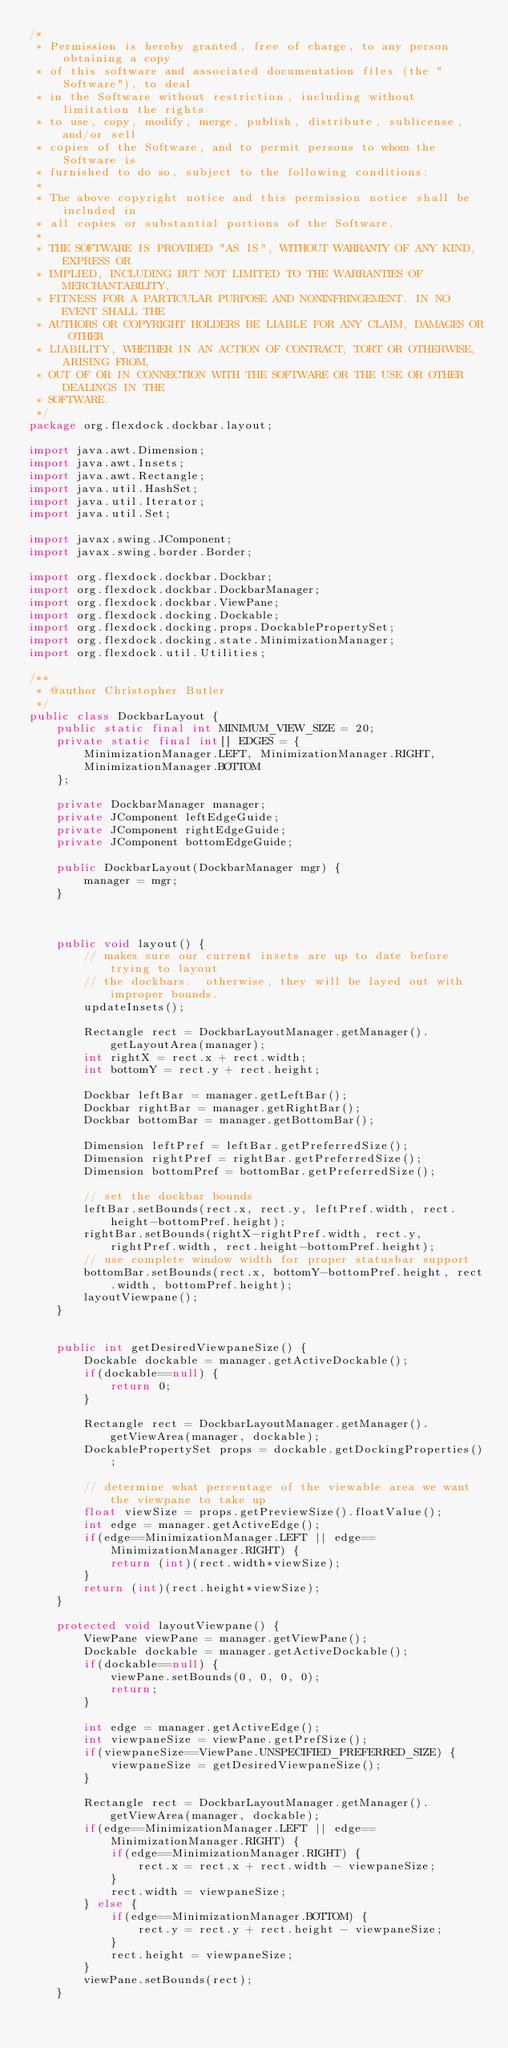<code> <loc_0><loc_0><loc_500><loc_500><_Java_>/*
 * Permission is hereby granted, free of charge, to any person obtaining a copy
 * of this software and associated documentation files (the "Software"), to deal
 * in the Software without restriction, including without limitation the rights
 * to use, copy, modify, merge, publish, distribute, sublicense, and/or sell
 * copies of the Software, and to permit persons to whom the Software is
 * furnished to do so, subject to the following conditions:
 *
 * The above copyright notice and this permission notice shall be included in
 * all copies or substantial portions of the Software.
 *
 * THE SOFTWARE IS PROVIDED "AS IS", WITHOUT WARRANTY OF ANY KIND, EXPRESS OR
 * IMPLIED, INCLUDING BUT NOT LIMITED TO THE WARRANTIES OF MERCHANTABILITY,
 * FITNESS FOR A PARTICULAR PURPOSE AND NONINFRINGEMENT. IN NO EVENT SHALL THE
 * AUTHORS OR COPYRIGHT HOLDERS BE LIABLE FOR ANY CLAIM, DAMAGES OR OTHER
 * LIABILITY, WHETHER IN AN ACTION OF CONTRACT, TORT OR OTHERWISE, ARISING FROM,
 * OUT OF OR IN CONNECTION WITH THE SOFTWARE OR THE USE OR OTHER DEALINGS IN THE
 * SOFTWARE.
 */
package org.flexdock.dockbar.layout;

import java.awt.Dimension;
import java.awt.Insets;
import java.awt.Rectangle;
import java.util.HashSet;
import java.util.Iterator;
import java.util.Set;

import javax.swing.JComponent;
import javax.swing.border.Border;

import org.flexdock.dockbar.Dockbar;
import org.flexdock.dockbar.DockbarManager;
import org.flexdock.dockbar.ViewPane;
import org.flexdock.docking.Dockable;
import org.flexdock.docking.props.DockablePropertySet;
import org.flexdock.docking.state.MinimizationManager;
import org.flexdock.util.Utilities;

/**
 * @author Christopher Butler
 */
public class DockbarLayout {
    public static final int MINIMUM_VIEW_SIZE = 20;
    private static final int[] EDGES = {
        MinimizationManager.LEFT, MinimizationManager.RIGHT,
        MinimizationManager.BOTTOM
    };

    private DockbarManager manager;
    private JComponent leftEdgeGuide;
    private JComponent rightEdgeGuide;
    private JComponent bottomEdgeGuide;

    public DockbarLayout(DockbarManager mgr) {
        manager = mgr;
    }



    public void layout() {
        // makes sure our current insets are up to date before trying to layout
        // the dockbars.  otherwise, they will be layed out with improper bounds.
        updateInsets();

        Rectangle rect = DockbarLayoutManager.getManager().getLayoutArea(manager);
        int rightX = rect.x + rect.width;
        int bottomY = rect.y + rect.height;

        Dockbar leftBar = manager.getLeftBar();
        Dockbar rightBar = manager.getRightBar();
        Dockbar bottomBar = manager.getBottomBar();

        Dimension leftPref = leftBar.getPreferredSize();
        Dimension rightPref = rightBar.getPreferredSize();
        Dimension bottomPref = bottomBar.getPreferredSize();

        // set the dockbar bounds
        leftBar.setBounds(rect.x, rect.y, leftPref.width, rect.height-bottomPref.height);
        rightBar.setBounds(rightX-rightPref.width, rect.y, rightPref.width, rect.height-bottomPref.height);
        // use complete window width for proper statusbar support
        bottomBar.setBounds(rect.x, bottomY-bottomPref.height, rect.width, bottomPref.height);
        layoutViewpane();
    }


    public int getDesiredViewpaneSize() {
        Dockable dockable = manager.getActiveDockable();
        if(dockable==null) {
            return 0;
        }

        Rectangle rect = DockbarLayoutManager.getManager().getViewArea(manager, dockable);
        DockablePropertySet props = dockable.getDockingProperties();

        // determine what percentage of the viewable area we want the viewpane to take up
        float viewSize = props.getPreviewSize().floatValue();
        int edge = manager.getActiveEdge();
        if(edge==MinimizationManager.LEFT || edge==MinimizationManager.RIGHT) {
            return (int)(rect.width*viewSize);
        }
        return (int)(rect.height*viewSize);
    }

    protected void layoutViewpane() {
        ViewPane viewPane = manager.getViewPane();
        Dockable dockable = manager.getActiveDockable();
        if(dockable==null) {
            viewPane.setBounds(0, 0, 0, 0);
            return;
        }

        int edge = manager.getActiveEdge();
        int viewpaneSize = viewPane.getPrefSize();
        if(viewpaneSize==ViewPane.UNSPECIFIED_PREFERRED_SIZE) {
            viewpaneSize = getDesiredViewpaneSize();
        }

        Rectangle rect = DockbarLayoutManager.getManager().getViewArea(manager, dockable);
        if(edge==MinimizationManager.LEFT || edge==MinimizationManager.RIGHT) {
            if(edge==MinimizationManager.RIGHT) {
                rect.x = rect.x + rect.width - viewpaneSize;
            }
            rect.width = viewpaneSize;
        } else {
            if(edge==MinimizationManager.BOTTOM) {
                rect.y = rect.y + rect.height - viewpaneSize;
            }
            rect.height = viewpaneSize;
        }
        viewPane.setBounds(rect);
    }

</code> 